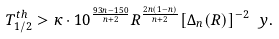Convert formula to latex. <formula><loc_0><loc_0><loc_500><loc_500>T _ { 1 / 2 } ^ { t h } > \kappa \cdot 1 0 ^ { \frac { 9 3 n - 1 5 0 } { n + 2 } } R ^ { \frac { 2 n ( 1 - n ) } { n + 2 } } [ \Delta _ { n } ( R ) ] ^ { - 2 } \ y .</formula> 